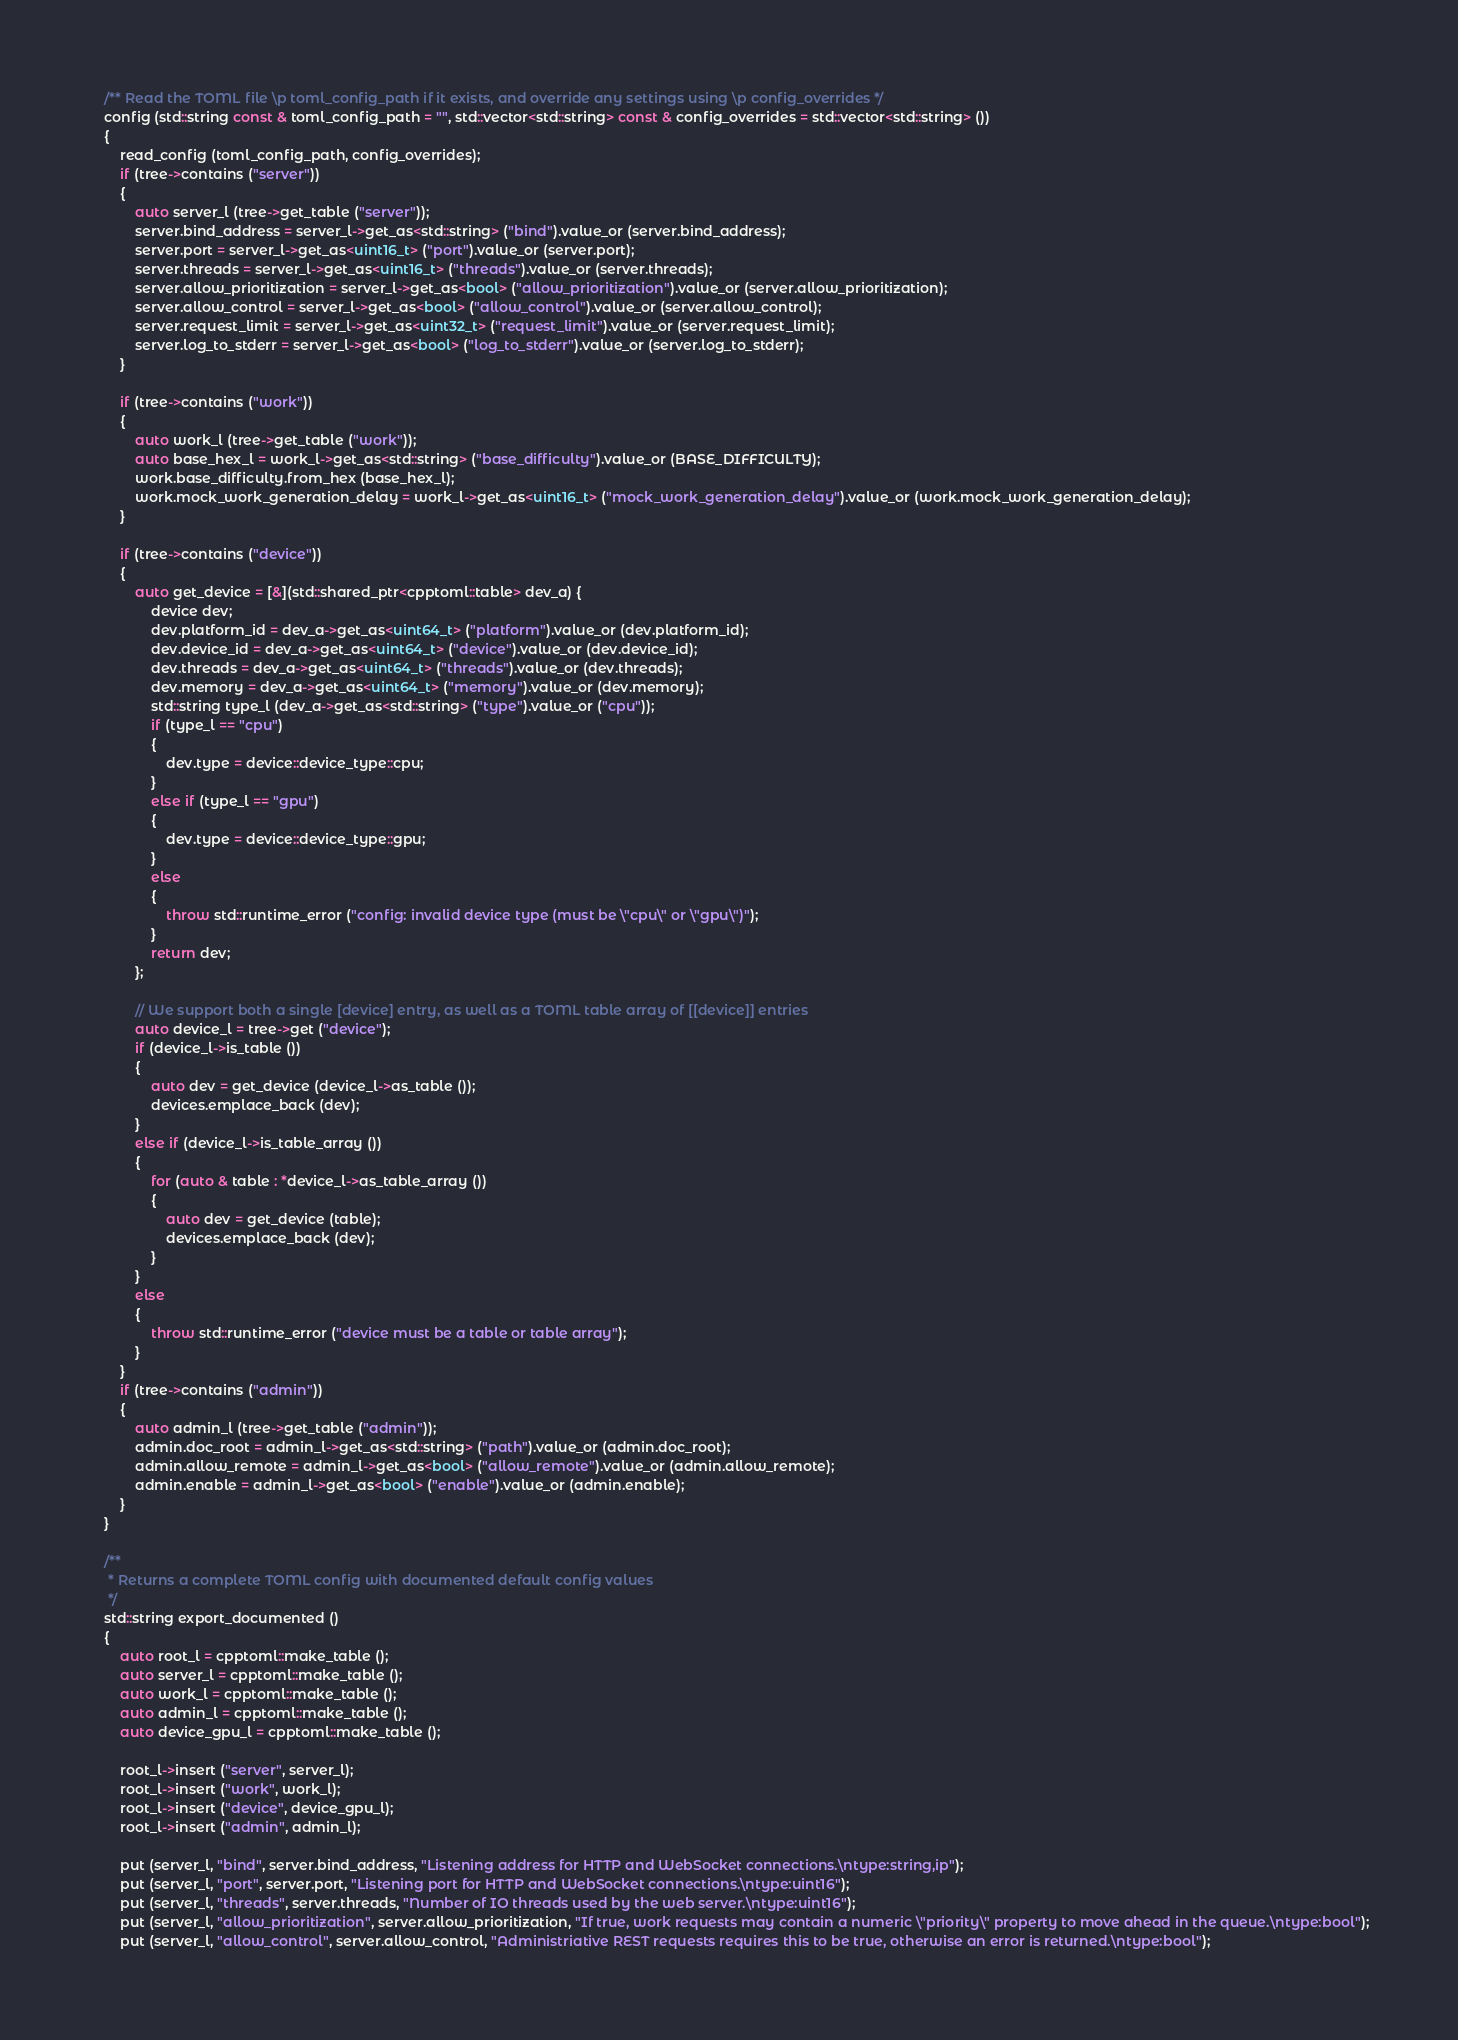Convert code to text. <code><loc_0><loc_0><loc_500><loc_500><_C++_>	/** Read the TOML file \p toml_config_path if it exists, and override any settings using \p config_overrides */
	config (std::string const & toml_config_path = "", std::vector<std::string> const & config_overrides = std::vector<std::string> ())
	{
		read_config (toml_config_path, config_overrides);
		if (tree->contains ("server"))
		{
			auto server_l (tree->get_table ("server"));
			server.bind_address = server_l->get_as<std::string> ("bind").value_or (server.bind_address);
			server.port = server_l->get_as<uint16_t> ("port").value_or (server.port);
			server.threads = server_l->get_as<uint16_t> ("threads").value_or (server.threads);
			server.allow_prioritization = server_l->get_as<bool> ("allow_prioritization").value_or (server.allow_prioritization);
			server.allow_control = server_l->get_as<bool> ("allow_control").value_or (server.allow_control);
			server.request_limit = server_l->get_as<uint32_t> ("request_limit").value_or (server.request_limit);
			server.log_to_stderr = server_l->get_as<bool> ("log_to_stderr").value_or (server.log_to_stderr);
		}

		if (tree->contains ("work"))
		{
			auto work_l (tree->get_table ("work"));
			auto base_hex_l = work_l->get_as<std::string> ("base_difficulty").value_or (BASE_DIFFICULTY);
			work.base_difficulty.from_hex (base_hex_l);
			work.mock_work_generation_delay = work_l->get_as<uint16_t> ("mock_work_generation_delay").value_or (work.mock_work_generation_delay);
		}

		if (tree->contains ("device"))
		{
			auto get_device = [&](std::shared_ptr<cpptoml::table> dev_a) {
				device dev;
				dev.platform_id = dev_a->get_as<uint64_t> ("platform").value_or (dev.platform_id);
				dev.device_id = dev_a->get_as<uint64_t> ("device").value_or (dev.device_id);
				dev.threads = dev_a->get_as<uint64_t> ("threads").value_or (dev.threads);
				dev.memory = dev_a->get_as<uint64_t> ("memory").value_or (dev.memory);
				std::string type_l (dev_a->get_as<std::string> ("type").value_or ("cpu"));
				if (type_l == "cpu")
				{
					dev.type = device::device_type::cpu;
				}
				else if (type_l == "gpu")
				{
					dev.type = device::device_type::gpu;
				}
				else
				{
					throw std::runtime_error ("config: invalid device type (must be \"cpu\" or \"gpu\")");
				}
				return dev;
			};

			// We support both a single [device] entry, as well as a TOML table array of [[device]] entries
			auto device_l = tree->get ("device");
			if (device_l->is_table ())
			{
				auto dev = get_device (device_l->as_table ());
				devices.emplace_back (dev);
			}
			else if (device_l->is_table_array ())
			{
				for (auto & table : *device_l->as_table_array ())
				{
					auto dev = get_device (table);
					devices.emplace_back (dev);
				}
			}
			else
			{
				throw std::runtime_error ("device must be a table or table array");
			}
		}
		if (tree->contains ("admin"))
		{
			auto admin_l (tree->get_table ("admin"));
			admin.doc_root = admin_l->get_as<std::string> ("path").value_or (admin.doc_root);
			admin.allow_remote = admin_l->get_as<bool> ("allow_remote").value_or (admin.allow_remote);
			admin.enable = admin_l->get_as<bool> ("enable").value_or (admin.enable);
		}
	}

	/**
	 * Returns a complete TOML config with documented default config values
	 */
	std::string export_documented ()
	{
		auto root_l = cpptoml::make_table ();
		auto server_l = cpptoml::make_table ();
		auto work_l = cpptoml::make_table ();
		auto admin_l = cpptoml::make_table ();
		auto device_gpu_l = cpptoml::make_table ();

		root_l->insert ("server", server_l);
		root_l->insert ("work", work_l);
		root_l->insert ("device", device_gpu_l);
		root_l->insert ("admin", admin_l);

		put (server_l, "bind", server.bind_address, "Listening address for HTTP and WebSocket connections.\ntype:string,ip");
		put (server_l, "port", server.port, "Listening port for HTTP and WebSocket connections.\ntype:uint16");
		put (server_l, "threads", server.threads, "Number of IO threads used by the web server.\ntype:uint16");
		put (server_l, "allow_prioritization", server.allow_prioritization, "If true, work requests may contain a numeric \"priority\" property to move ahead in the queue.\ntype:bool");
		put (server_l, "allow_control", server.allow_control, "Administriative REST requests requires this to be true, otherwise an error is returned.\ntype:bool");</code> 